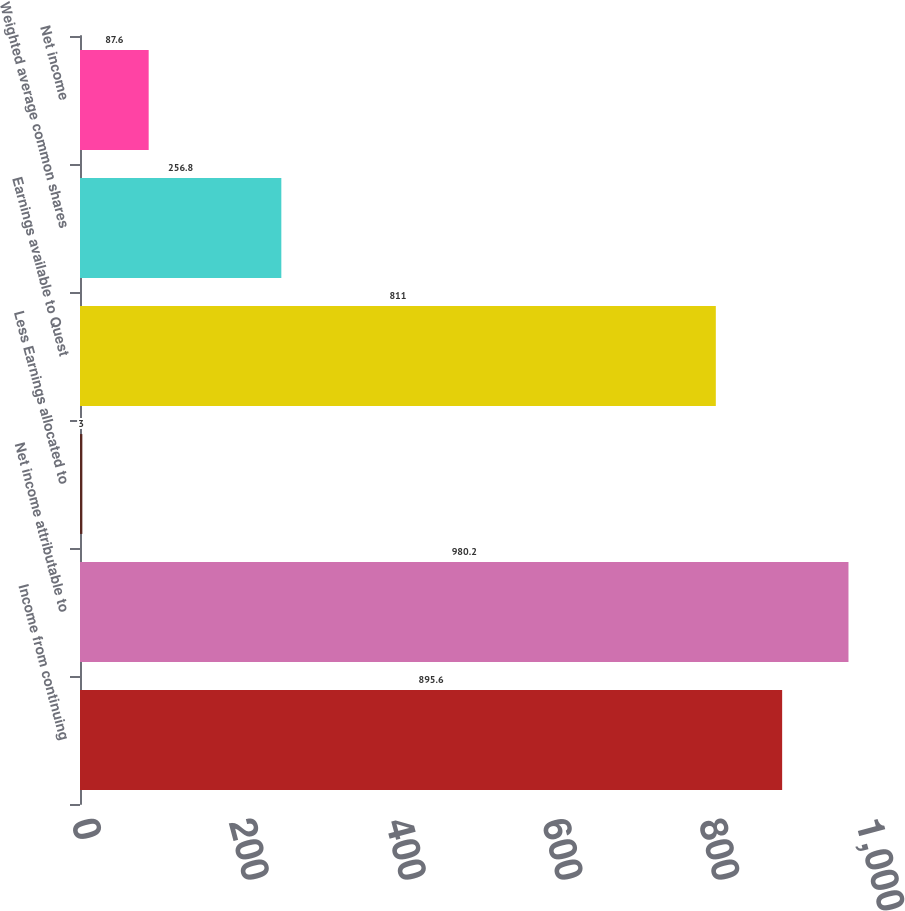Convert chart to OTSL. <chart><loc_0><loc_0><loc_500><loc_500><bar_chart><fcel>Income from continuing<fcel>Net income attributable to<fcel>Less Earnings allocated to<fcel>Earnings available to Quest<fcel>Weighted average common shares<fcel>Net income<nl><fcel>895.6<fcel>980.2<fcel>3<fcel>811<fcel>256.8<fcel>87.6<nl></chart> 